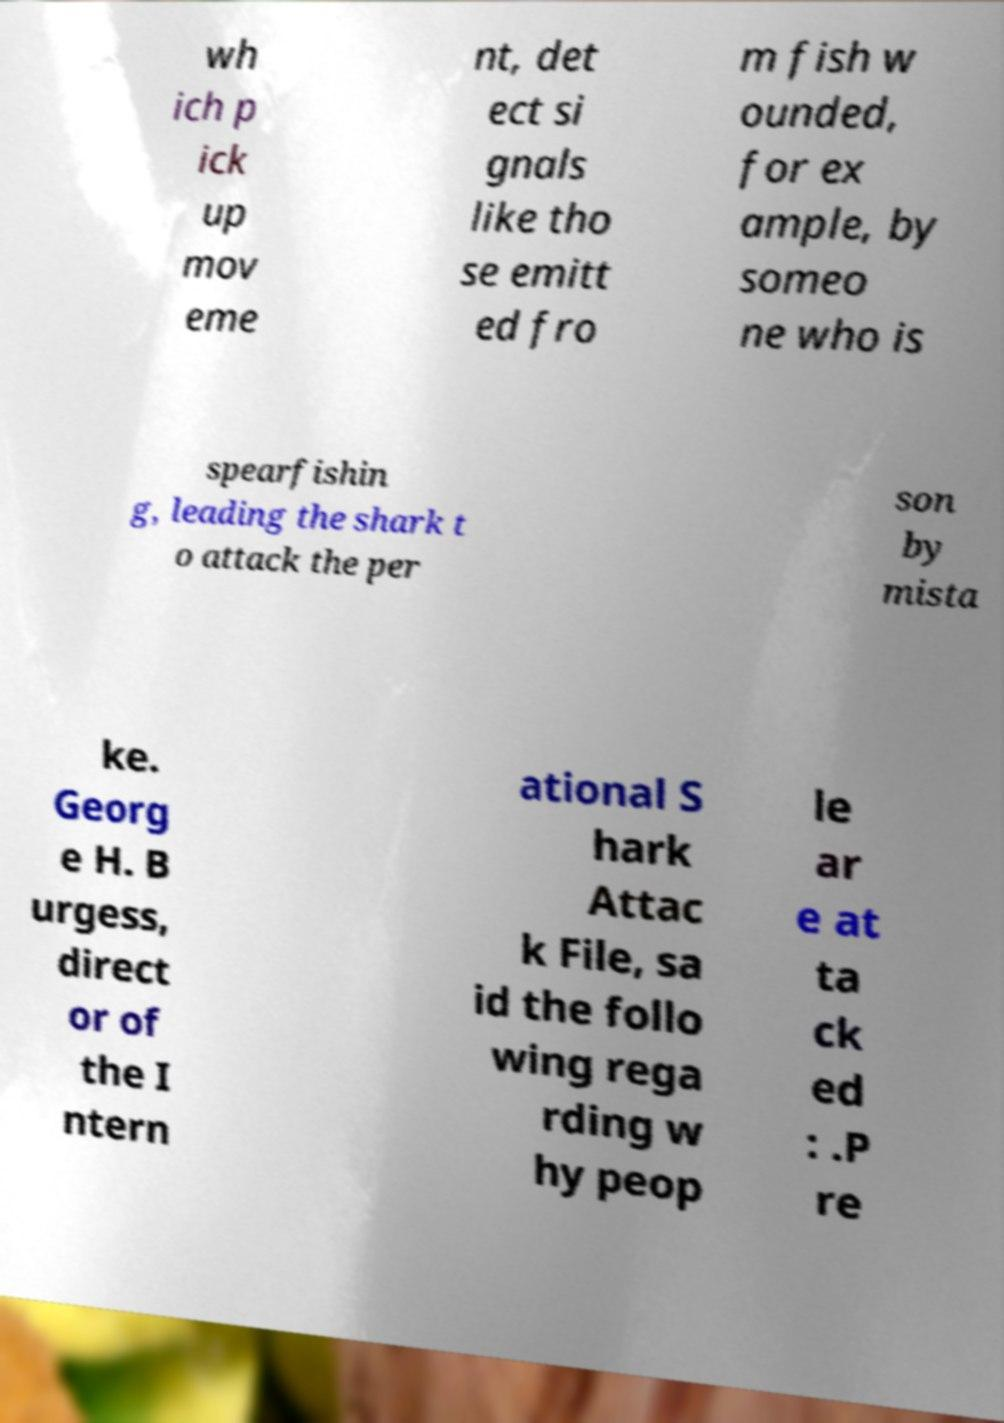Please identify and transcribe the text found in this image. wh ich p ick up mov eme nt, det ect si gnals like tho se emitt ed fro m fish w ounded, for ex ample, by someo ne who is spearfishin g, leading the shark t o attack the per son by mista ke. Georg e H. B urgess, direct or of the I ntern ational S hark Attac k File, sa id the follo wing rega rding w hy peop le ar e at ta ck ed : .P re 